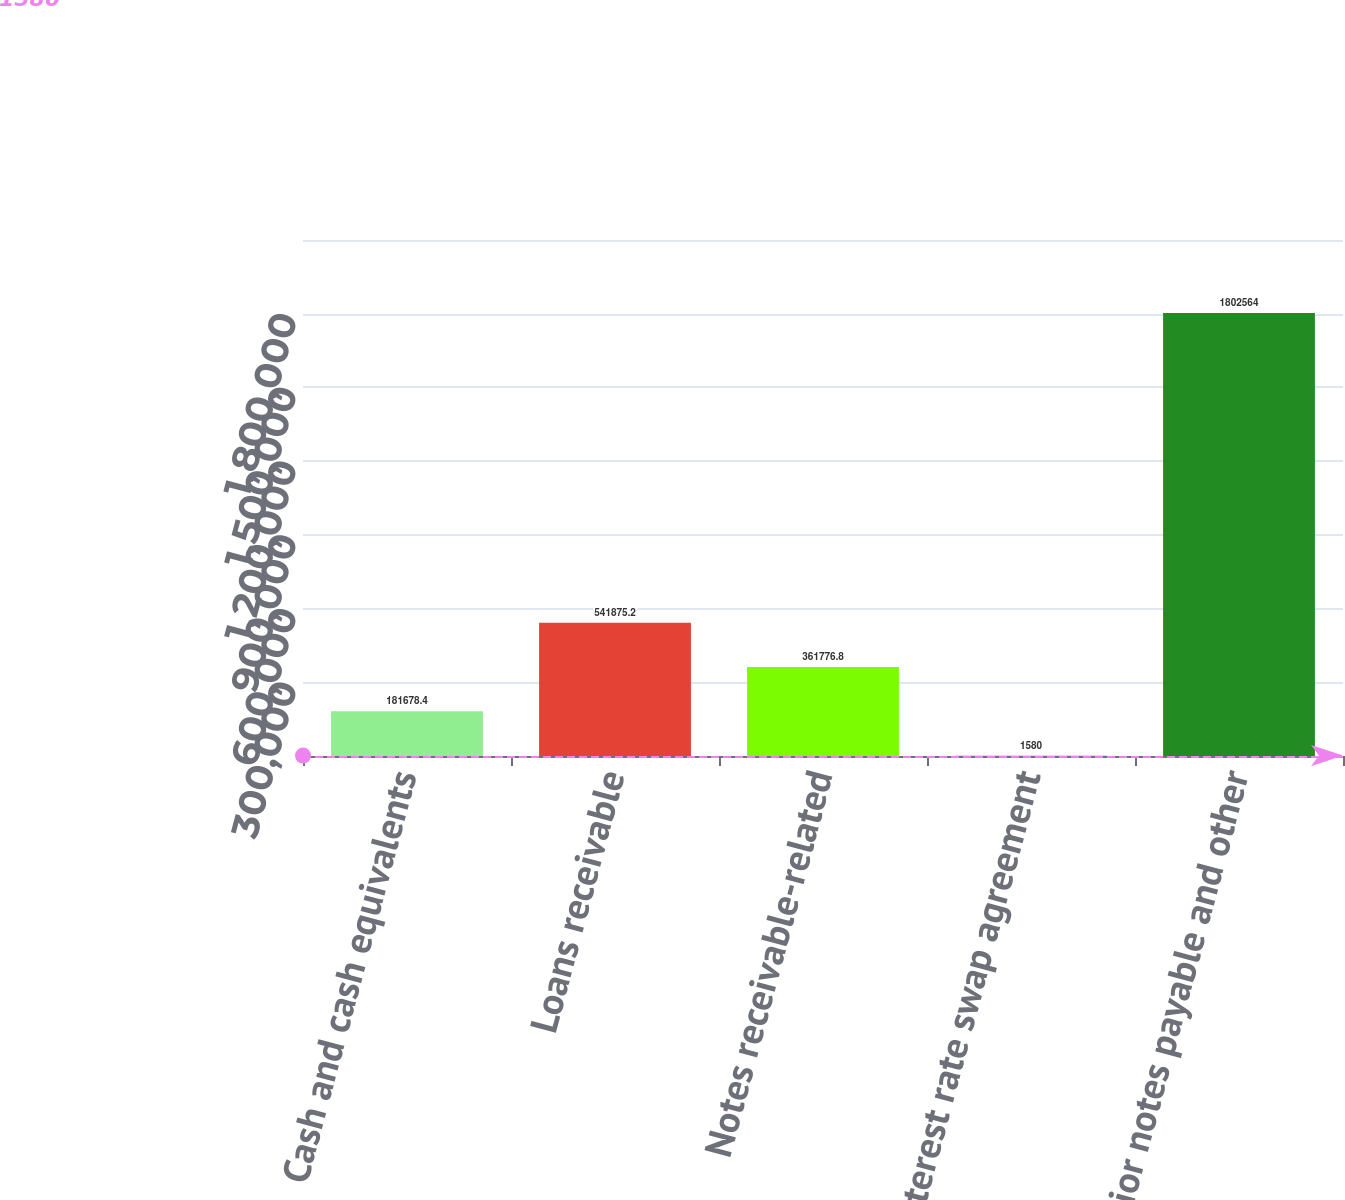Convert chart. <chart><loc_0><loc_0><loc_500><loc_500><bar_chart><fcel>Cash and cash equivalents<fcel>Loans receivable<fcel>Notes receivable-related<fcel>Interest rate swap agreement<fcel>Senior notes payable and other<nl><fcel>181678<fcel>541875<fcel>361777<fcel>1580<fcel>1.80256e+06<nl></chart> 